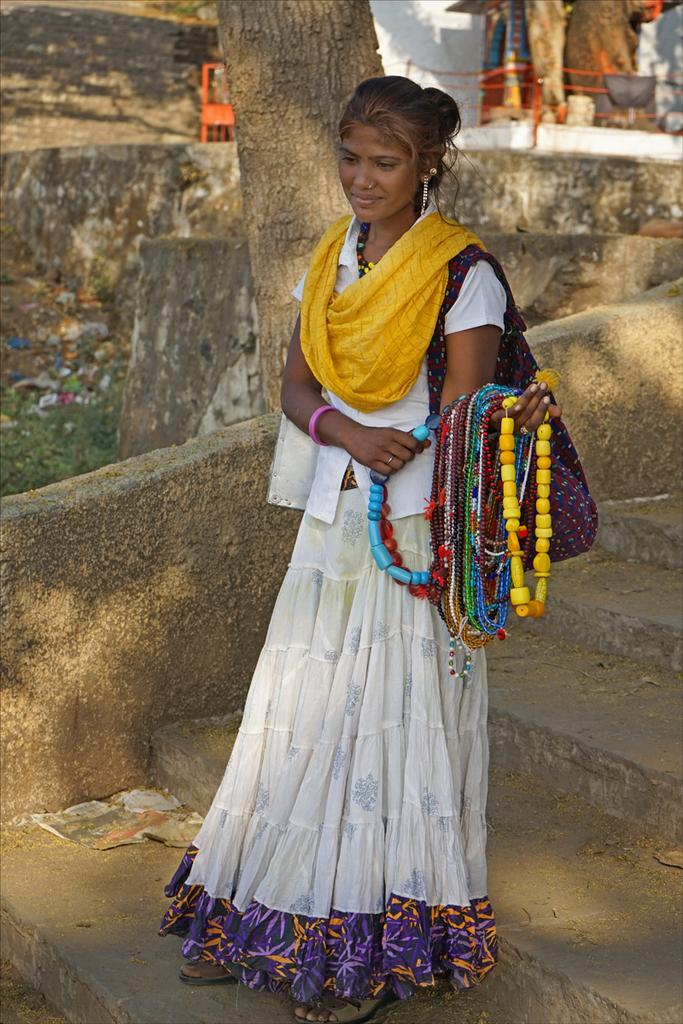Who is present in the image? There is a woman in the image. What is the woman doing in the image? The woman is standing on the stairs and holding ornaments in her hands. What can be seen in the background of the image? There is a tree visible in the image, and its tree bark is also visible. What is the woman wearing in the image? The woman is wearing a bag. What type of stem is the woman holding in her hands? The woman is not holding a stem in her hands; she is holding ornaments. 